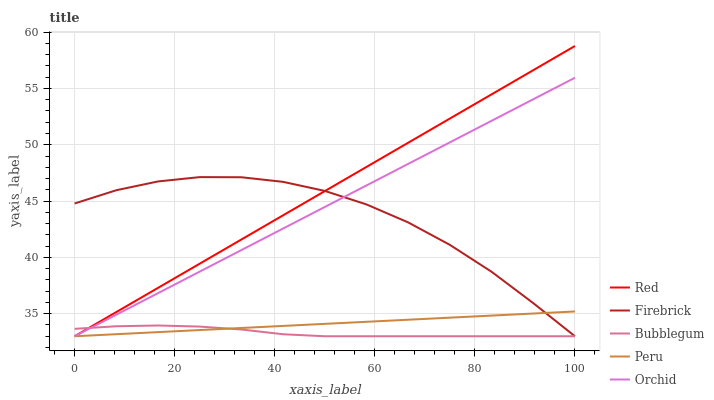Does Bubblegum have the minimum area under the curve?
Answer yes or no. Yes. Does Red have the maximum area under the curve?
Answer yes or no. Yes. Does Firebrick have the minimum area under the curve?
Answer yes or no. No. Does Firebrick have the maximum area under the curve?
Answer yes or no. No. Is Peru the smoothest?
Answer yes or no. Yes. Is Firebrick the roughest?
Answer yes or no. Yes. Is Bubblegum the smoothest?
Answer yes or no. No. Is Bubblegum the roughest?
Answer yes or no. No. Does Peru have the lowest value?
Answer yes or no. Yes. Does Red have the highest value?
Answer yes or no. Yes. Does Firebrick have the highest value?
Answer yes or no. No. Does Bubblegum intersect Red?
Answer yes or no. Yes. Is Bubblegum less than Red?
Answer yes or no. No. Is Bubblegum greater than Red?
Answer yes or no. No. 